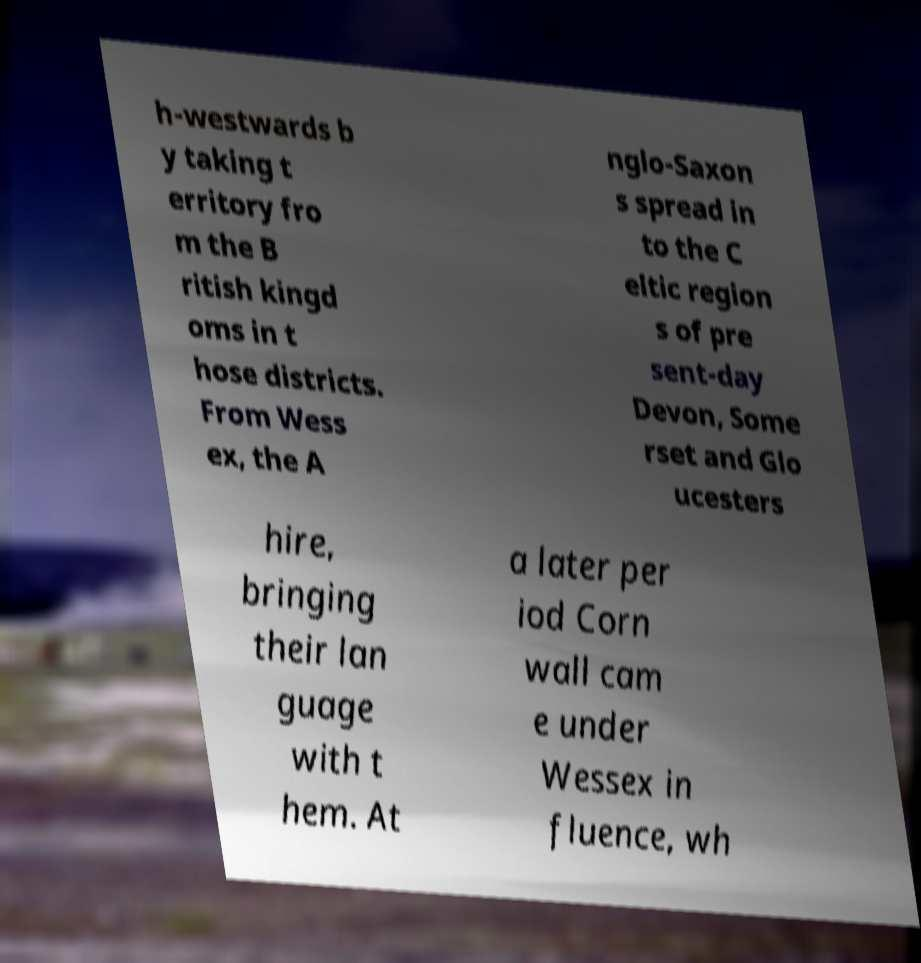I need the written content from this picture converted into text. Can you do that? h-westwards b y taking t erritory fro m the B ritish kingd oms in t hose districts. From Wess ex, the A nglo-Saxon s spread in to the C eltic region s of pre sent-day Devon, Some rset and Glo ucesters hire, bringing their lan guage with t hem. At a later per iod Corn wall cam e under Wessex in fluence, wh 